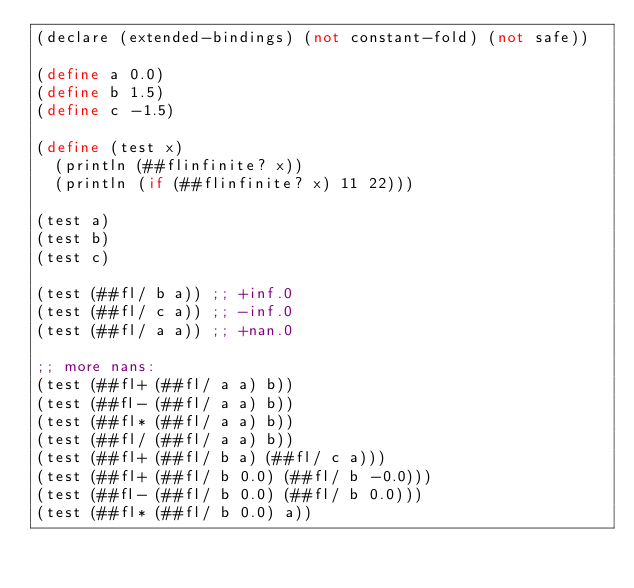<code> <loc_0><loc_0><loc_500><loc_500><_Scheme_>(declare (extended-bindings) (not constant-fold) (not safe))

(define a 0.0)
(define b 1.5)
(define c -1.5)

(define (test x)
  (println (##flinfinite? x))
  (println (if (##flinfinite? x) 11 22)))

(test a)
(test b)
(test c)

(test (##fl/ b a)) ;; +inf.0
(test (##fl/ c a)) ;; -inf.0
(test (##fl/ a a)) ;; +nan.0

;; more nans:
(test (##fl+ (##fl/ a a) b))
(test (##fl- (##fl/ a a) b))
(test (##fl* (##fl/ a a) b))
(test (##fl/ (##fl/ a a) b))
(test (##fl+ (##fl/ b a) (##fl/ c a)))
(test (##fl+ (##fl/ b 0.0) (##fl/ b -0.0)))
(test (##fl- (##fl/ b 0.0) (##fl/ b 0.0)))
(test (##fl* (##fl/ b 0.0) a))
</code> 